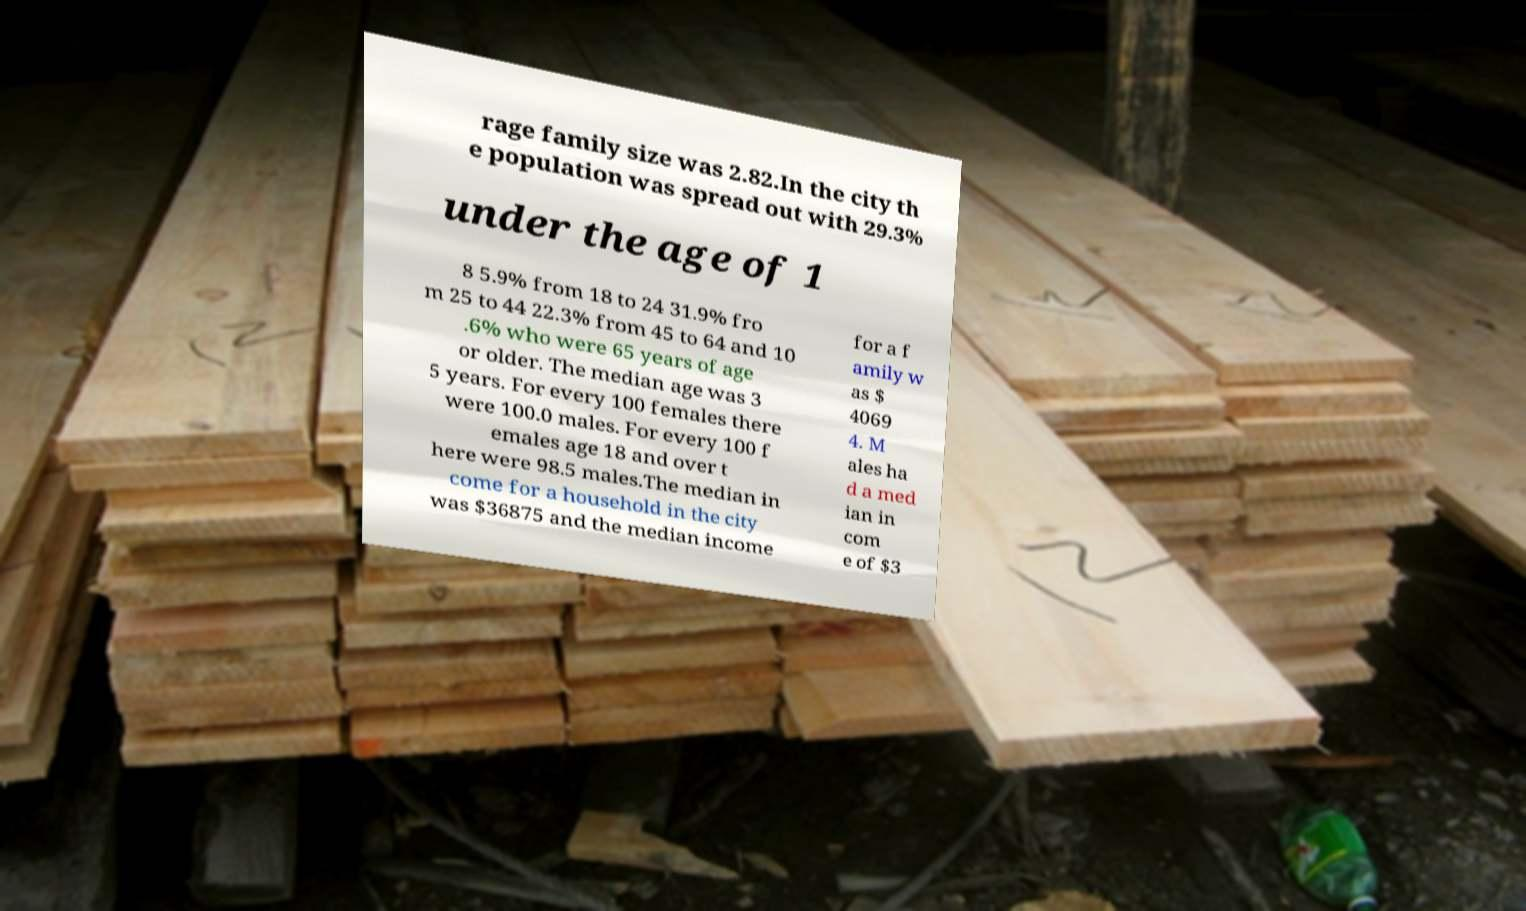Could you extract and type out the text from this image? rage family size was 2.82.In the city th e population was spread out with 29.3% under the age of 1 8 5.9% from 18 to 24 31.9% fro m 25 to 44 22.3% from 45 to 64 and 10 .6% who were 65 years of age or older. The median age was 3 5 years. For every 100 females there were 100.0 males. For every 100 f emales age 18 and over t here were 98.5 males.The median in come for a household in the city was $36875 and the median income for a f amily w as $ 4069 4. M ales ha d a med ian in com e of $3 